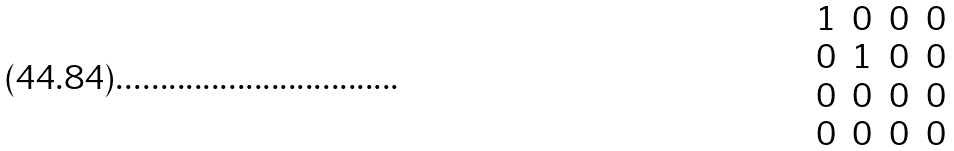Convert formula to latex. <formula><loc_0><loc_0><loc_500><loc_500>\begin{matrix} 1 & 0 & 0 & 0 \\ 0 & 1 & 0 & 0 \\ 0 & 0 & 0 & 0 \\ 0 & 0 & 0 & 0 \end{matrix}</formula> 